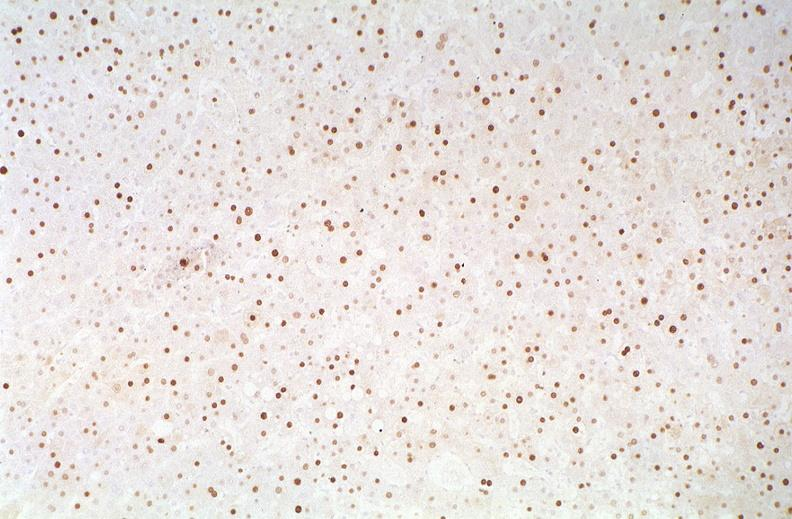what does this image show?
Answer the question using a single word or phrase. Hepatitis b virus 